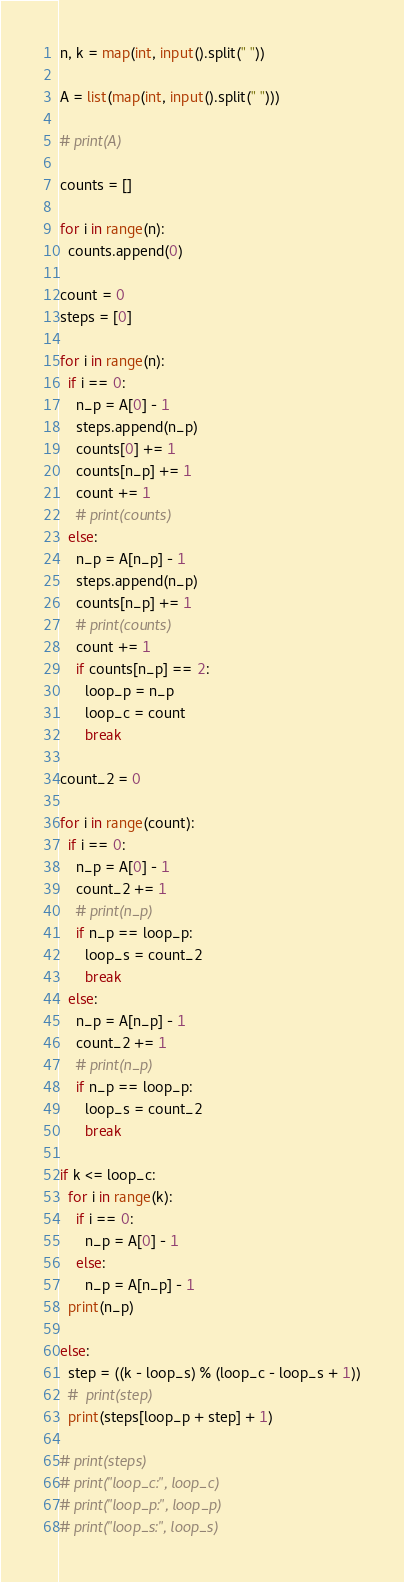<code> <loc_0><loc_0><loc_500><loc_500><_Python_>n, k = map(int, input().split(" "))

A = list(map(int, input().split(" ")))

# print(A)

counts = []

for i in range(n):
  counts.append(0)

count = 0
steps = [0]

for i in range(n):
  if i == 0:
    n_p = A[0] - 1
    steps.append(n_p)
    counts[0] += 1
    counts[n_p] += 1
    count += 1
    # print(counts)
  else:
    n_p = A[n_p] - 1
    steps.append(n_p)
    counts[n_p] += 1
    # print(counts)
    count += 1
    if counts[n_p] == 2:
      loop_p = n_p
      loop_c = count
      break

count_2 = 0      
      
for i in range(count):
  if i == 0:
    n_p = A[0] - 1
    count_2 += 1
    # print(n_p)
    if n_p == loop_p:
      loop_s = count_2
      break
  else:
    n_p = A[n_p] - 1
    count_2 += 1
    # print(n_p)
    if n_p == loop_p:
      loop_s = count_2
      break

if k <= loop_c:
  for i in range(k):
    if i == 0:
      n_p = A[0] - 1
    else:
      n_p = A[n_p] - 1
  print(n_p)
  
else:
  step = ((k - loop_s) % (loop_c - loop_s + 1))
  #  print(step)
  print(steps[loop_p + step] + 1)
  
# print(steps) 
# print("loop_c:", loop_c)
# print("loop_p:", loop_p)
# print("loop_s:", loop_s)</code> 